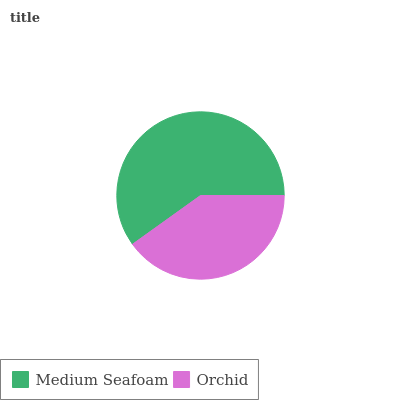Is Orchid the minimum?
Answer yes or no. Yes. Is Medium Seafoam the maximum?
Answer yes or no. Yes. Is Orchid the maximum?
Answer yes or no. No. Is Medium Seafoam greater than Orchid?
Answer yes or no. Yes. Is Orchid less than Medium Seafoam?
Answer yes or no. Yes. Is Orchid greater than Medium Seafoam?
Answer yes or no. No. Is Medium Seafoam less than Orchid?
Answer yes or no. No. Is Medium Seafoam the high median?
Answer yes or no. Yes. Is Orchid the low median?
Answer yes or no. Yes. Is Orchid the high median?
Answer yes or no. No. Is Medium Seafoam the low median?
Answer yes or no. No. 